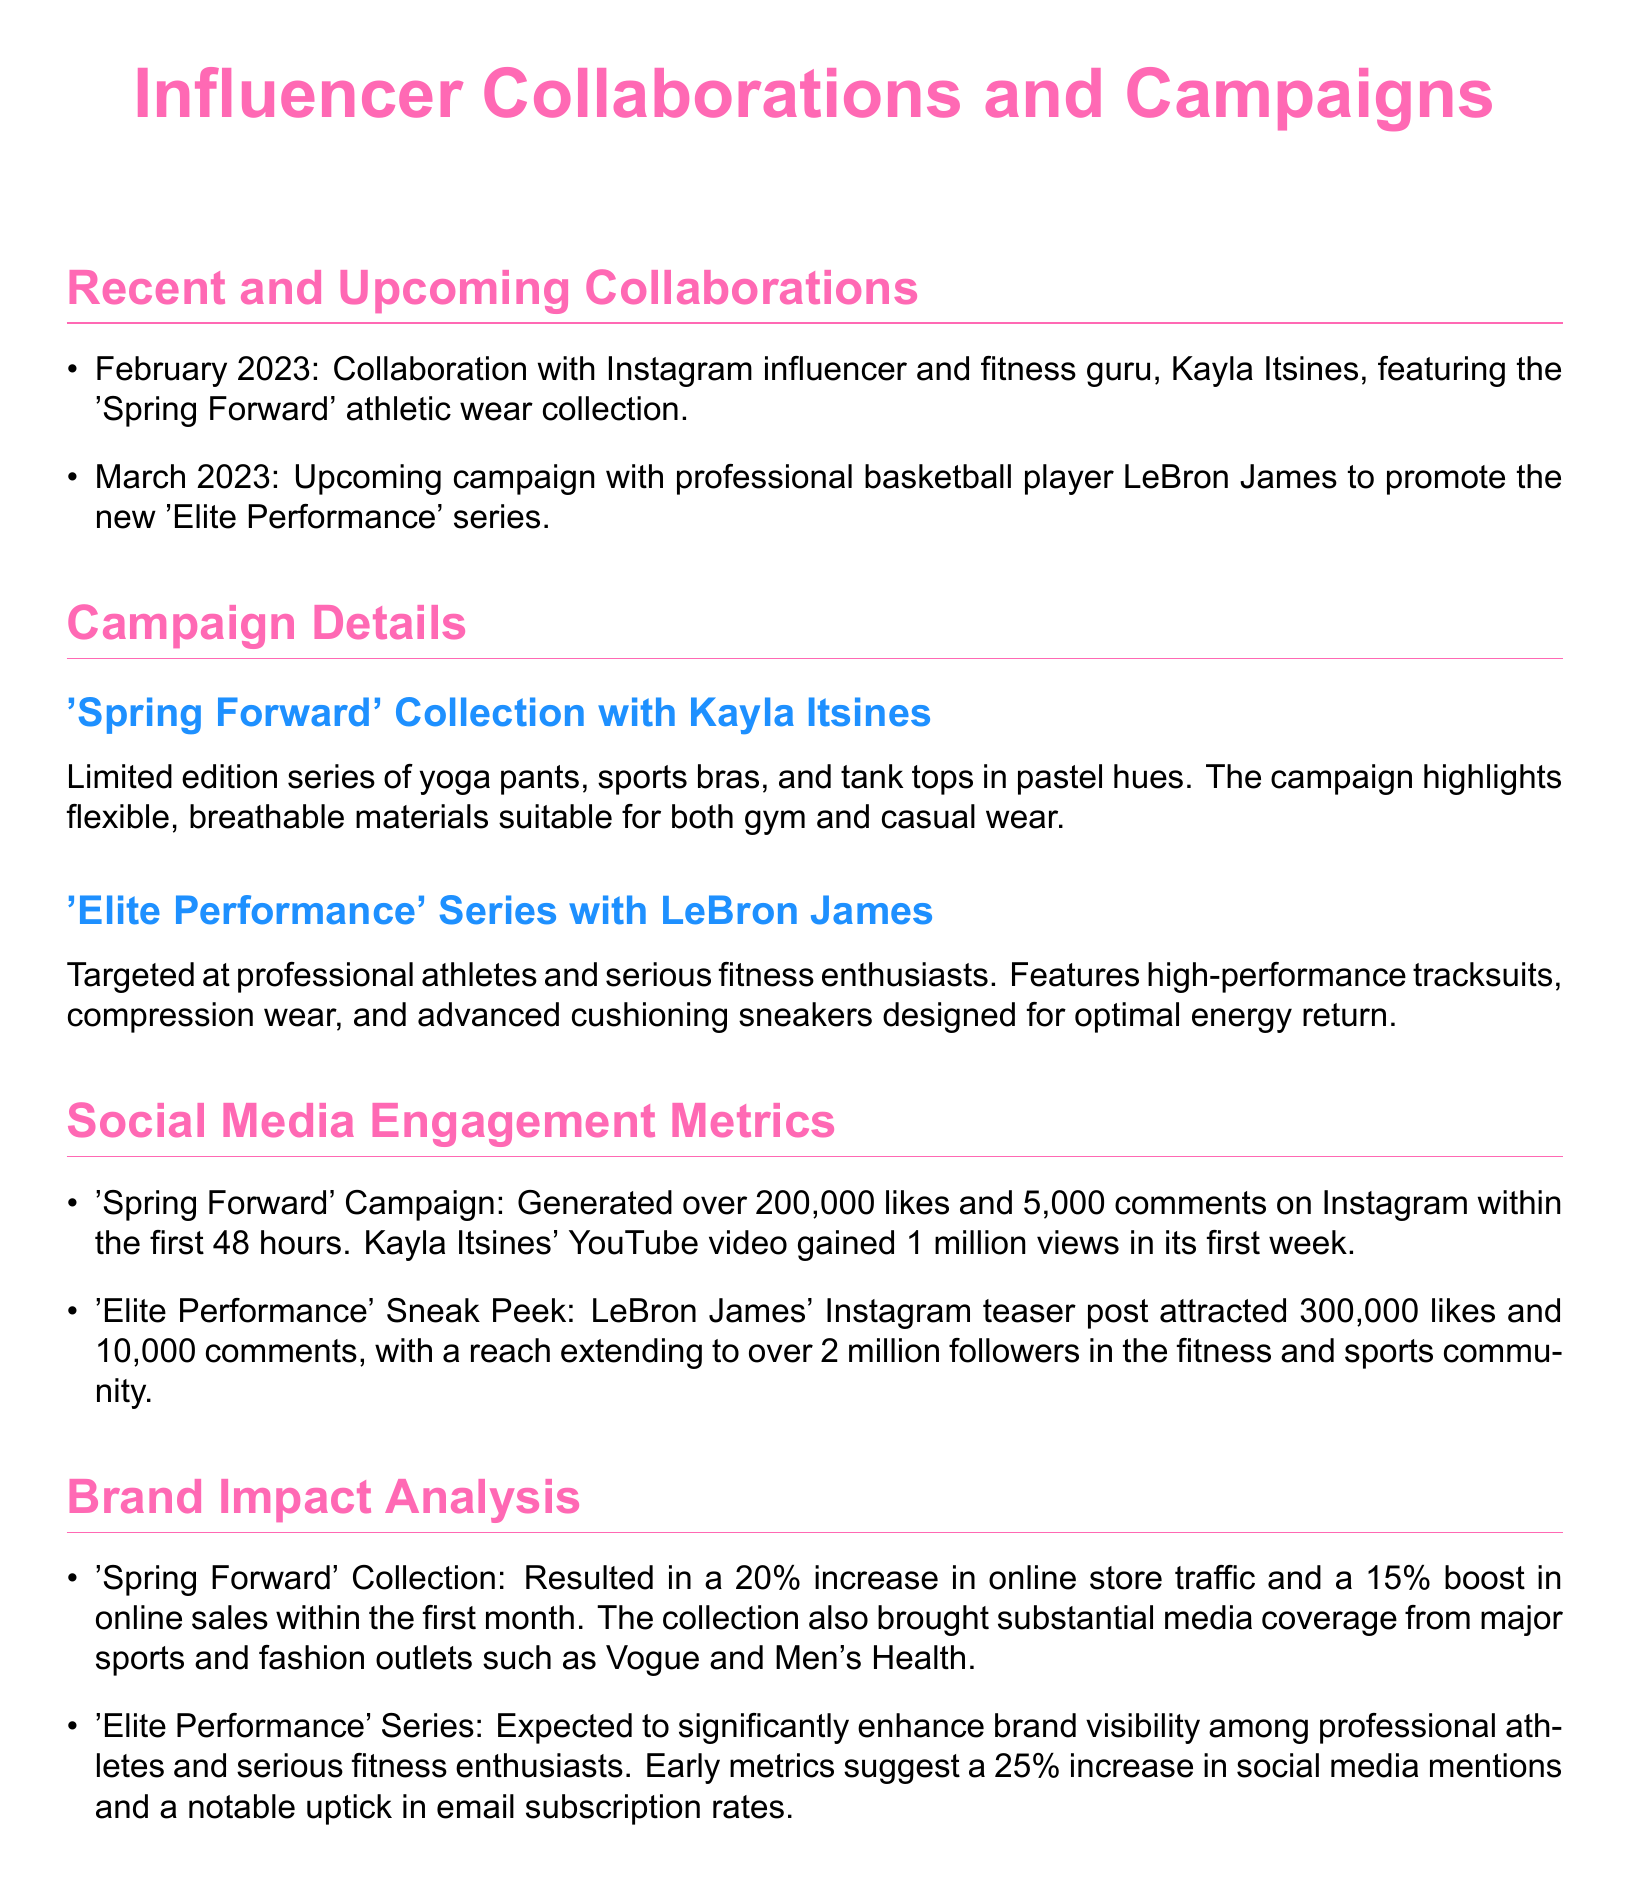What is the name of the collection launched in February 2023? The February 2023 collaboration is specifically mentioned as the 'Spring Forward' athletic wear collection.
Answer: 'Spring Forward' Who is collaborating with the brand for the 'Elite Performance' series? The document states that the collaboration for the 'Elite Performance' series is with professional basketball player LeBron James.
Answer: LeBron James How many likes did the 'Spring Forward' campaign generate on Instagram within the first 48 hours? The document indicates that the 'Spring Forward' campaign generated over 200,000 likes on Instagram within the specified timeframe.
Answer: 200,000 What percentage increase in online sales was observed for the 'Spring Forward' collection? According to the document, there was a 15% boost in online sales within the first month for the 'Spring Forward' collection.
Answer: 15% What materials are highlighted in the 'Spring Forward' collection? The campaign highlights flexible, breathable materials suitable for both gym and casual wear, as stated in the document.
Answer: Flexible, breathable materials What is the expected increase in social media mentions for the 'Elite Performance' series? The early metrics suggest a 25% increase in social media mentions for the 'Elite Performance' series, as stated in the brand impact analysis.
Answer: 25% How many comments did LeBron James' Instagram teaser post receive? The document mentions that LeBron James' Instagram teaser post attracted 10,000 comments.
Answer: 10,000 What kind of products are featured in the 'Elite Performance' series? The 'Elite Performance' series features high-performance tracksuits, compression wear, and advanced cushioning sneakers.
Answer: High-performance tracksuits, compression wear, advanced cushioning sneakers 